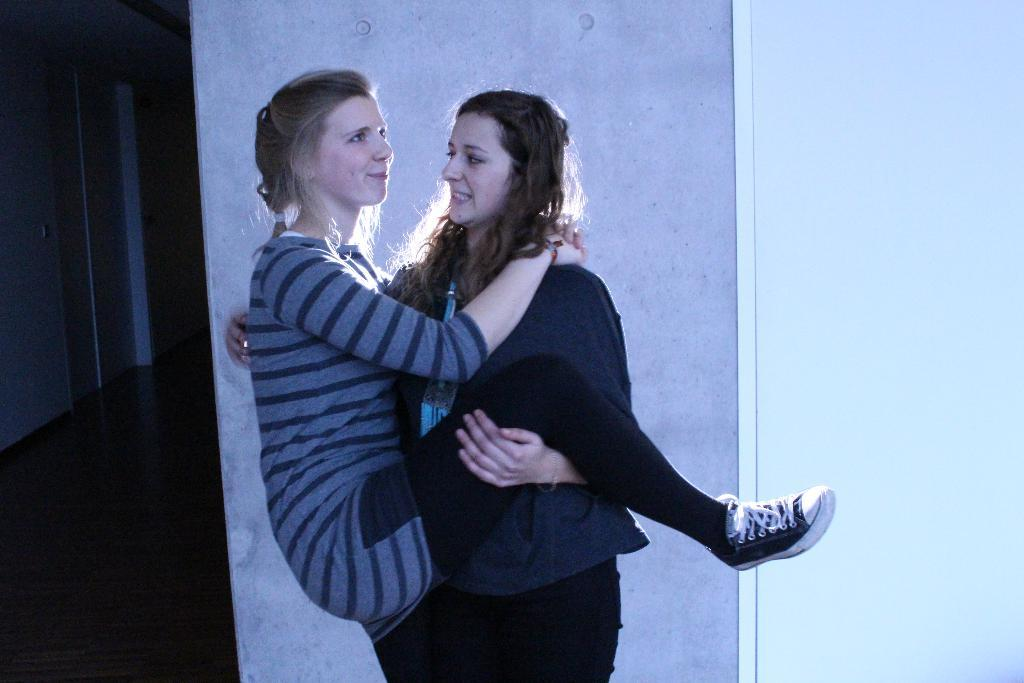What type of structure can be seen in the background of the image? There are walls in the background of the image. What is located at the left bottom of the image? There is a floor at the left bottom of the image. How many women are in the image? There are two women in the middle of the image. What type of debt is the woman on the right side of the image dealing with? There is no mention of debt in the image, so it cannot be determined. 